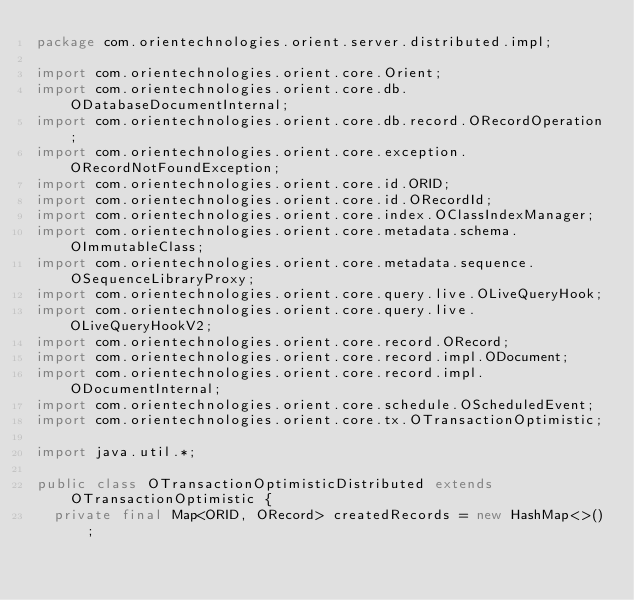Convert code to text. <code><loc_0><loc_0><loc_500><loc_500><_Java_>package com.orientechnologies.orient.server.distributed.impl;

import com.orientechnologies.orient.core.Orient;
import com.orientechnologies.orient.core.db.ODatabaseDocumentInternal;
import com.orientechnologies.orient.core.db.record.ORecordOperation;
import com.orientechnologies.orient.core.exception.ORecordNotFoundException;
import com.orientechnologies.orient.core.id.ORID;
import com.orientechnologies.orient.core.id.ORecordId;
import com.orientechnologies.orient.core.index.OClassIndexManager;
import com.orientechnologies.orient.core.metadata.schema.OImmutableClass;
import com.orientechnologies.orient.core.metadata.sequence.OSequenceLibraryProxy;
import com.orientechnologies.orient.core.query.live.OLiveQueryHook;
import com.orientechnologies.orient.core.query.live.OLiveQueryHookV2;
import com.orientechnologies.orient.core.record.ORecord;
import com.orientechnologies.orient.core.record.impl.ODocument;
import com.orientechnologies.orient.core.record.impl.ODocumentInternal;
import com.orientechnologies.orient.core.schedule.OScheduledEvent;
import com.orientechnologies.orient.core.tx.OTransactionOptimistic;

import java.util.*;

public class OTransactionOptimisticDistributed extends OTransactionOptimistic {
  private final Map<ORID, ORecord> createdRecords = new HashMap<>();</code> 